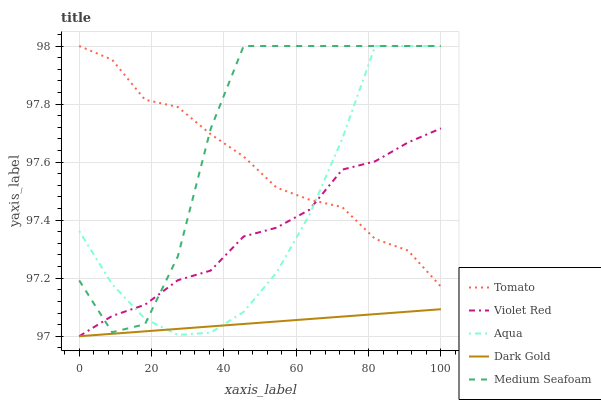Does Dark Gold have the minimum area under the curve?
Answer yes or no. Yes. Does Medium Seafoam have the maximum area under the curve?
Answer yes or no. Yes. Does Violet Red have the minimum area under the curve?
Answer yes or no. No. Does Violet Red have the maximum area under the curve?
Answer yes or no. No. Is Dark Gold the smoothest?
Answer yes or no. Yes. Is Medium Seafoam the roughest?
Answer yes or no. Yes. Is Violet Red the smoothest?
Answer yes or no. No. Is Violet Red the roughest?
Answer yes or no. No. Does Violet Red have the lowest value?
Answer yes or no. Yes. Does Aqua have the lowest value?
Answer yes or no. No. Does Medium Seafoam have the highest value?
Answer yes or no. Yes. Does Violet Red have the highest value?
Answer yes or no. No. Is Dark Gold less than Medium Seafoam?
Answer yes or no. Yes. Is Medium Seafoam greater than Dark Gold?
Answer yes or no. Yes. Does Aqua intersect Violet Red?
Answer yes or no. Yes. Is Aqua less than Violet Red?
Answer yes or no. No. Is Aqua greater than Violet Red?
Answer yes or no. No. Does Dark Gold intersect Medium Seafoam?
Answer yes or no. No. 